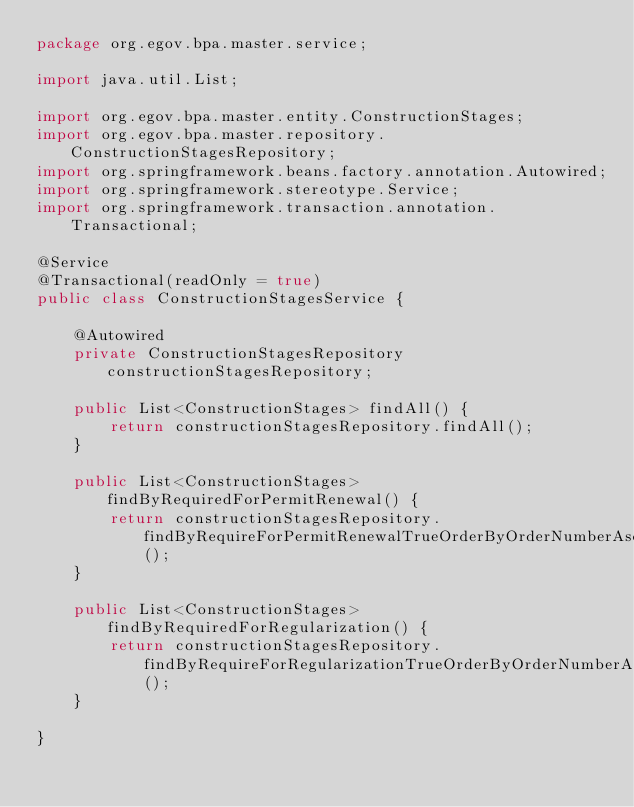<code> <loc_0><loc_0><loc_500><loc_500><_Java_>package org.egov.bpa.master.service;

import java.util.List;

import org.egov.bpa.master.entity.ConstructionStages;
import org.egov.bpa.master.repository.ConstructionStagesRepository;
import org.springframework.beans.factory.annotation.Autowired;
import org.springframework.stereotype.Service;
import org.springframework.transaction.annotation.Transactional;

@Service
@Transactional(readOnly = true)
public class ConstructionStagesService {

    @Autowired
    private ConstructionStagesRepository constructionStagesRepository;

    public List<ConstructionStages> findAll() {
        return constructionStagesRepository.findAll();
    }

    public List<ConstructionStages> findByRequiredForPermitRenewal() {
        return constructionStagesRepository.findByRequireForPermitRenewalTrueOrderByOrderNumberAsc();
    }

    public List<ConstructionStages> findByRequiredForRegularization() {
        return constructionStagesRepository.findByRequireForRegularizationTrueOrderByOrderNumberAsc();
    }

}
</code> 